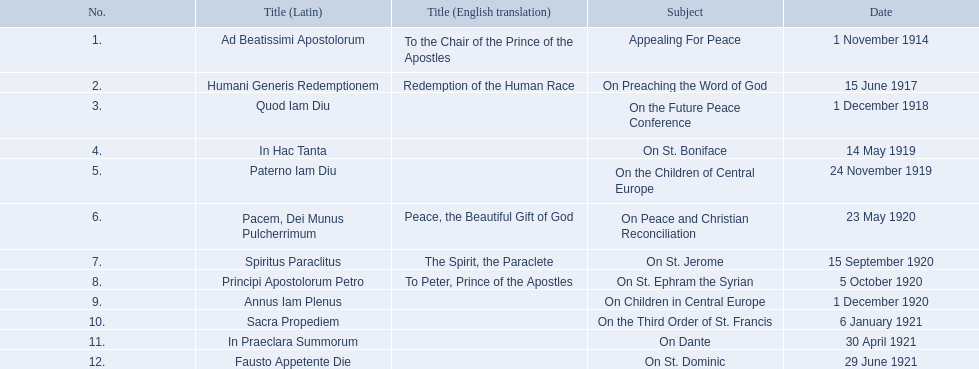What are all the subjects? Appealing For Peace, On Preaching the Word of God, On the Future Peace Conference, On St. Boniface, On the Children of Central Europe, On Peace and Christian Reconciliation, On St. Jerome, On St. Ephram the Syrian, On Children in Central Europe, On the Third Order of St. Francis, On Dante, On St. Dominic. Which occurred in 1920? On Peace and Christian Reconciliation, On St. Jerome, On St. Ephram the Syrian, On Children in Central Europe. Which occurred in may of that year? On Peace and Christian Reconciliation. Can you parse all the data within this table? {'header': ['No.', 'Title (Latin)', 'Title (English translation)', 'Subject', 'Date'], 'rows': [['1.', 'Ad Beatissimi Apostolorum', 'To the Chair of the Prince of the Apostles', 'Appealing For Peace', '1 November 1914'], ['2.', 'Humani Generis Redemptionem', 'Redemption of the Human Race', 'On Preaching the Word of God', '15 June 1917'], ['3.', 'Quod Iam Diu', '', 'On the Future Peace Conference', '1 December 1918'], ['4.', 'In Hac Tanta', '', 'On St. Boniface', '14 May 1919'], ['5.', 'Paterno Iam Diu', '', 'On the Children of Central Europe', '24 November 1919'], ['6.', 'Pacem, Dei Munus Pulcherrimum', 'Peace, the Beautiful Gift of God', 'On Peace and Christian Reconciliation', '23 May 1920'], ['7.', 'Spiritus Paraclitus', 'The Spirit, the Paraclete', 'On St. Jerome', '15 September 1920'], ['8.', 'Principi Apostolorum Petro', 'To Peter, Prince of the Apostles', 'On St. Ephram the Syrian', '5 October 1920'], ['9.', 'Annus Iam Plenus', '', 'On Children in Central Europe', '1 December 1920'], ['10.', 'Sacra Propediem', '', 'On the Third Order of St. Francis', '6 January 1921'], ['11.', 'In Praeclara Summorum', '', 'On Dante', '30 April 1921'], ['12.', 'Fausto Appetente Die', '', 'On St. Dominic', '29 June 1921']]} 